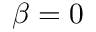Convert formula to latex. <formula><loc_0><loc_0><loc_500><loc_500>\beta = 0</formula> 